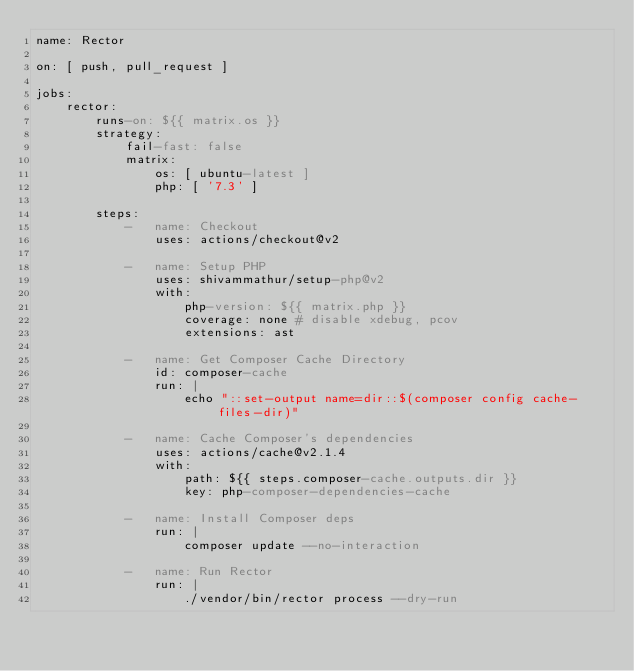Convert code to text. <code><loc_0><loc_0><loc_500><loc_500><_YAML_>name: Rector

on: [ push, pull_request ]

jobs:
    rector:
        runs-on: ${{ matrix.os }}
        strategy:
            fail-fast: false
            matrix:
                os: [ ubuntu-latest ]
                php: [ '7.3' ]

        steps:
            -   name: Checkout
                uses: actions/checkout@v2

            -   name: Setup PHP
                uses: shivammathur/setup-php@v2
                with:
                    php-version: ${{ matrix.php }}
                    coverage: none # disable xdebug, pcov
                    extensions: ast

            -   name: Get Composer Cache Directory
                id: composer-cache
                run: |
                    echo "::set-output name=dir::$(composer config cache-files-dir)"

            -   name: Cache Composer's dependencies
                uses: actions/cache@v2.1.4
                with:
                    path: ${{ steps.composer-cache.outputs.dir }}
                    key: php-composer-dependencies-cache

            -   name: Install Composer deps
                run: |
                    composer update --no-interaction

            -   name: Run Rector
                run: |
                    ./vendor/bin/rector process --dry-run
</code> 